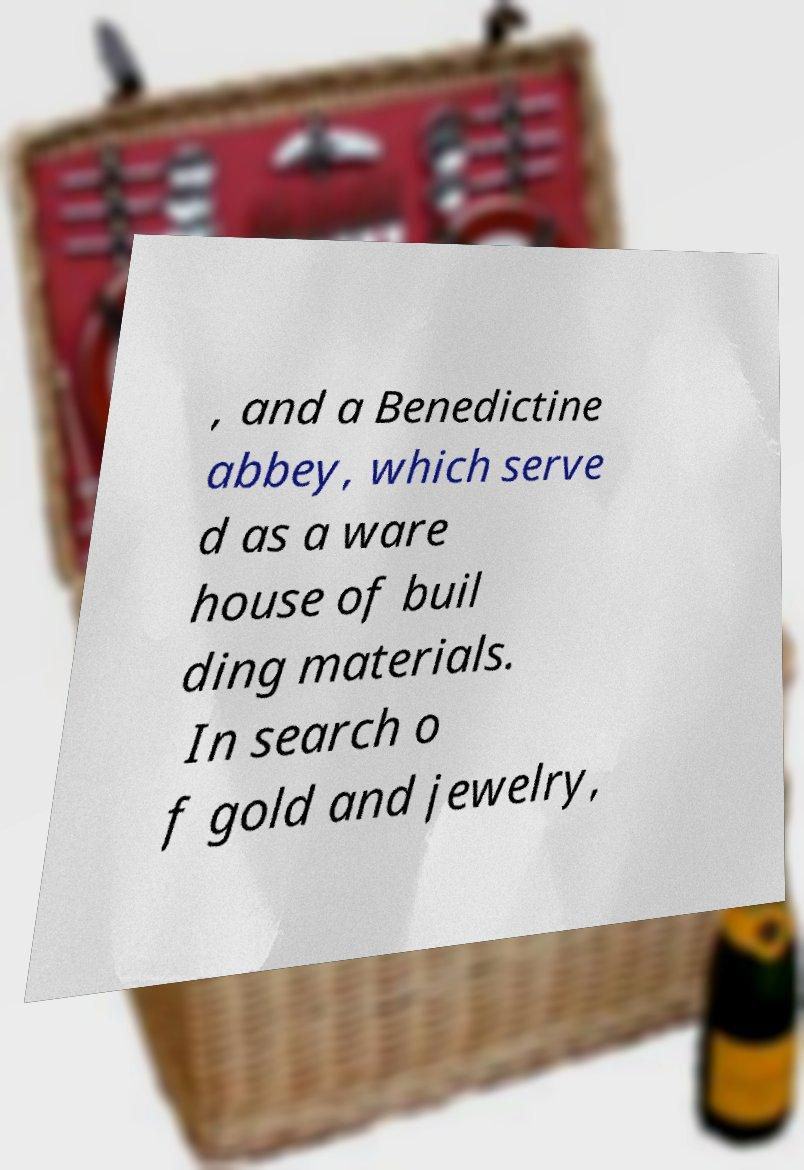I need the written content from this picture converted into text. Can you do that? , and a Benedictine abbey, which serve d as a ware house of buil ding materials. In search o f gold and jewelry, 